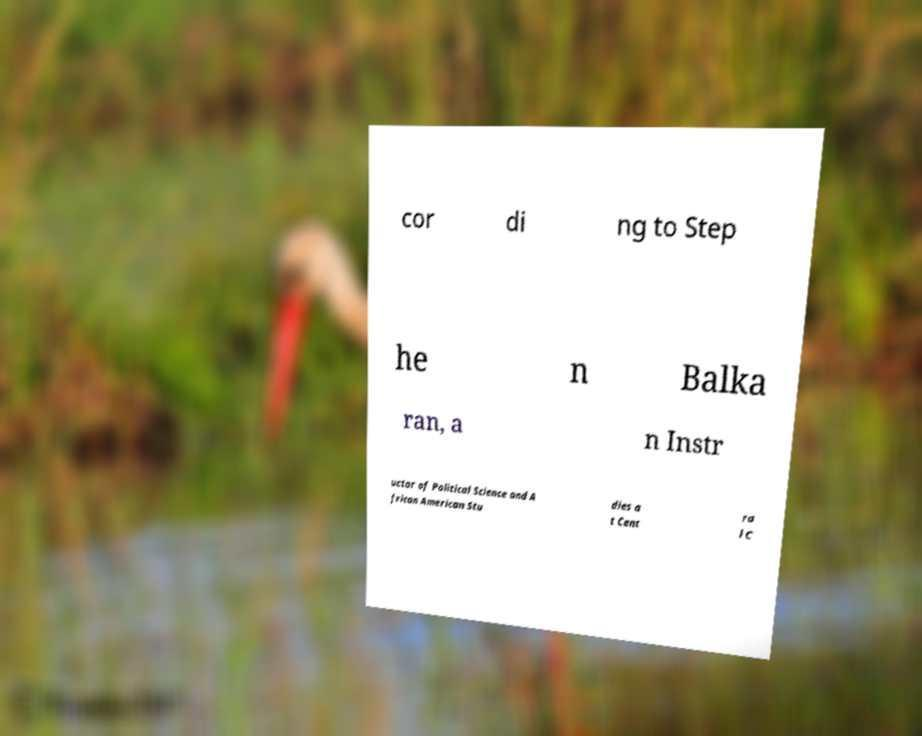Can you accurately transcribe the text from the provided image for me? cor di ng to Step he n Balka ran, a n Instr uctor of Political Science and A frican American Stu dies a t Cent ra l C 